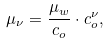<formula> <loc_0><loc_0><loc_500><loc_500>\mu _ { \nu } = \frac { \mu _ { w } } { c _ { o } } \cdot c _ { o } ^ { \nu } ,</formula> 